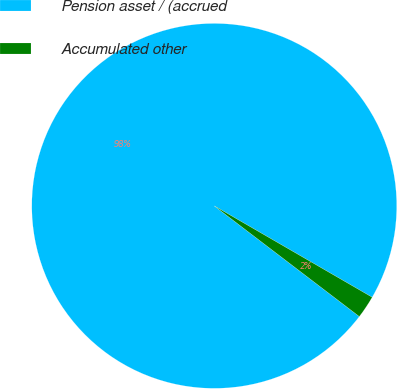Convert chart to OTSL. <chart><loc_0><loc_0><loc_500><loc_500><pie_chart><fcel>Pension asset / (accrued<fcel>Accumulated other<nl><fcel>97.98%<fcel>2.02%<nl></chart> 